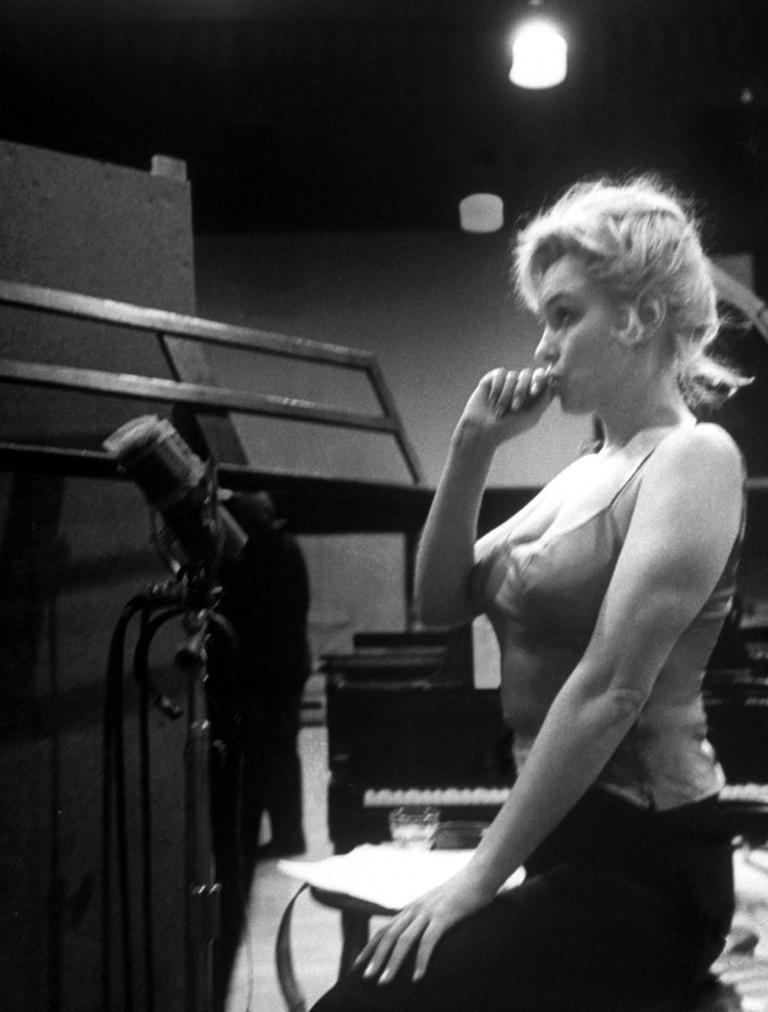Describe this image in one or two sentences. In the foreground of this image, there is a woman sitting on the right of this image. On the left, there is a mic, a stand and an object behind it. In the background, there is a person, musical instrument and lights at the top. 